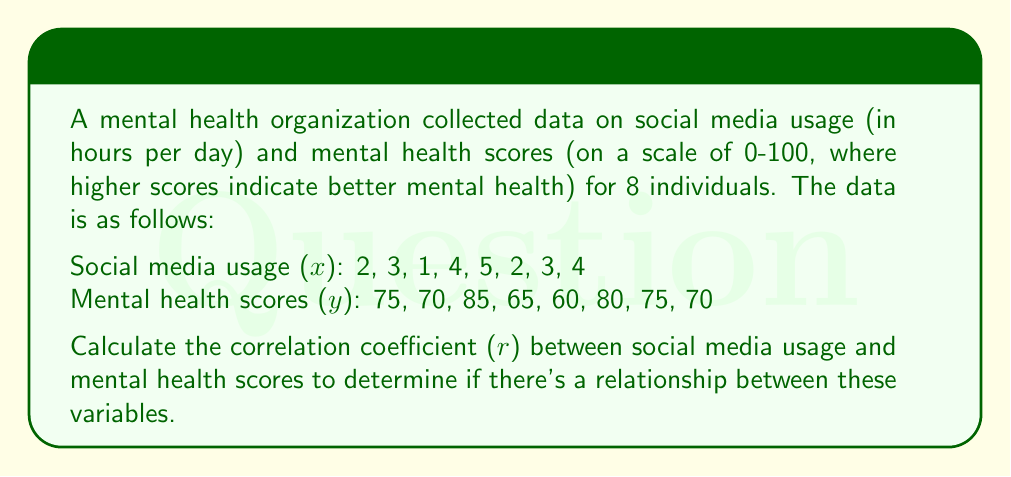Teach me how to tackle this problem. To calculate the correlation coefficient (r), we'll use the formula:

$$ r = \frac{n\sum xy - \sum x \sum y}{\sqrt{[n\sum x^2 - (\sum x)^2][n\sum y^2 - (\sum y)^2]}} $$

Step 1: Calculate the required sums:
$\sum x = 24$
$\sum y = 580$
$\sum xy = 1710$
$\sum x^2 = 86$
$\sum y^2 = 42550$
$n = 8$

Step 2: Substitute these values into the formula:

$$ r = \frac{8(1710) - (24)(580)}{\sqrt{[8(86) - (24)^2][8(42550) - (580)^2]}} $$

Step 3: Simplify:

$$ r = \frac{13680 - 13920}{\sqrt{(688 - 576)(340400 - 336400)}} $$

$$ r = \frac{-240}{\sqrt{(112)(4000)}} $$

$$ r = \frac{-240}{\sqrt{448000}} $$

$$ r = \frac{-240}{669.33} $$

Step 4: Calculate the final result:

$$ r \approx -0.3585 $$
Answer: $r \approx -0.3585$ 